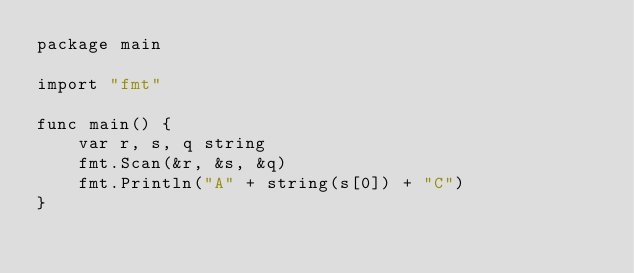Convert code to text. <code><loc_0><loc_0><loc_500><loc_500><_Go_>package main

import "fmt"

func main() {
	var r, s, q string
	fmt.Scan(&r, &s, &q)
	fmt.Println("A" + string(s[0]) + "C")
}
</code> 